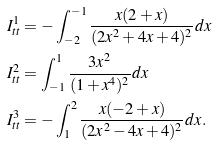<formula> <loc_0><loc_0><loc_500><loc_500>I _ { t t } ^ { 1 } & = - \int _ { - 2 } ^ { - 1 } \frac { x ( 2 + x ) } { ( 2 x ^ { 2 } + 4 x + 4 ) ^ { 2 } } d x \\ I _ { t t } ^ { 2 } & = \int _ { - 1 } ^ { 1 } \frac { 3 x ^ { 2 } } { ( 1 + x ^ { 4 } ) ^ { 2 } } d x \\ I _ { t t } ^ { 3 } & = - \int _ { 1 } ^ { 2 } \frac { x ( - 2 + x ) } { ( 2 x ^ { 2 } - 4 x + 4 ) ^ { 2 } } d x . \\</formula> 